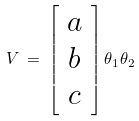<formula> <loc_0><loc_0><loc_500><loc_500>V \, = \, \left [ \begin{array} { c } a \\ b \\ c \end{array} \right ] \theta _ { 1 } \theta _ { 2 }</formula> 